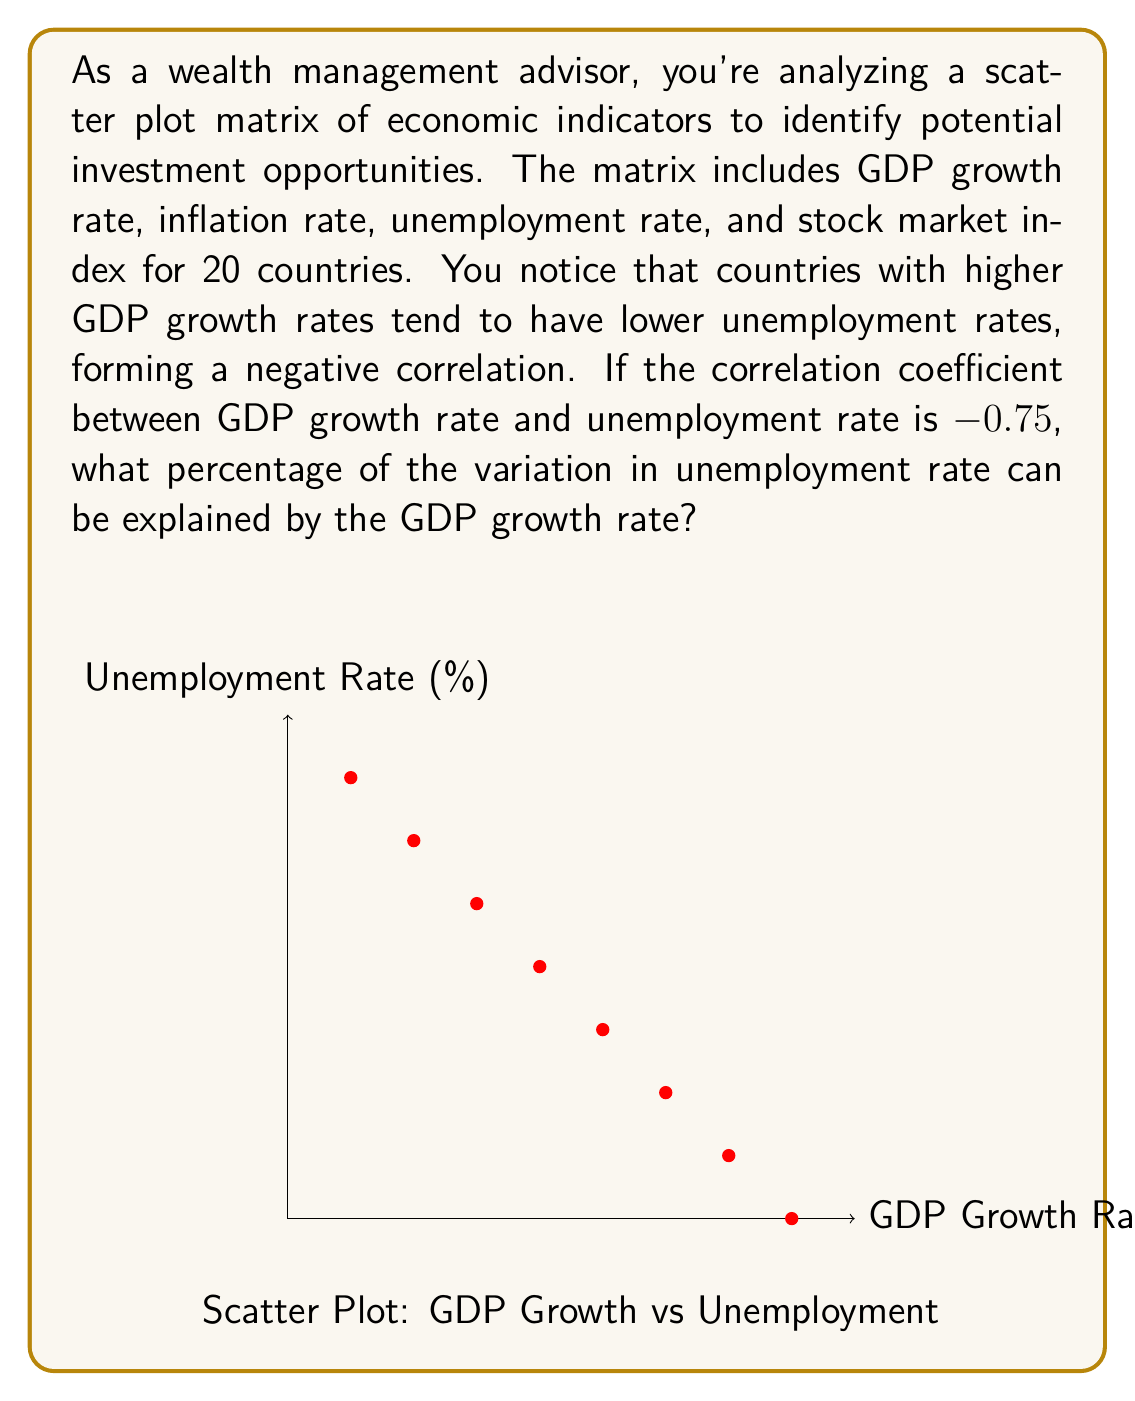Can you answer this question? To solve this problem, we need to understand the concept of the coefficient of determination, also known as R-squared (R²). This value represents the proportion of variance in the dependent variable (unemployment rate) that is predictable from the independent variable (GDP growth rate).

Steps to solve:

1) The correlation coefficient (r) is given as -0.75.

2) The coefficient of determination (R²) is the square of the correlation coefficient:

   $$R^2 = r^2$$

3) Substitute the given value:

   $$R^2 = (-0.75)^2 = 0.5625$$

4) Convert to a percentage:

   $$0.5625 \times 100\% = 56.25\%$$

This means that 56.25% of the variation in the unemployment rate can be explained by the GDP growth rate.

The negative correlation (-0.75) indicates an inverse relationship, meaning as GDP growth increases, unemployment tends to decrease, which is consistent with general economic theory.
Answer: 56.25% 